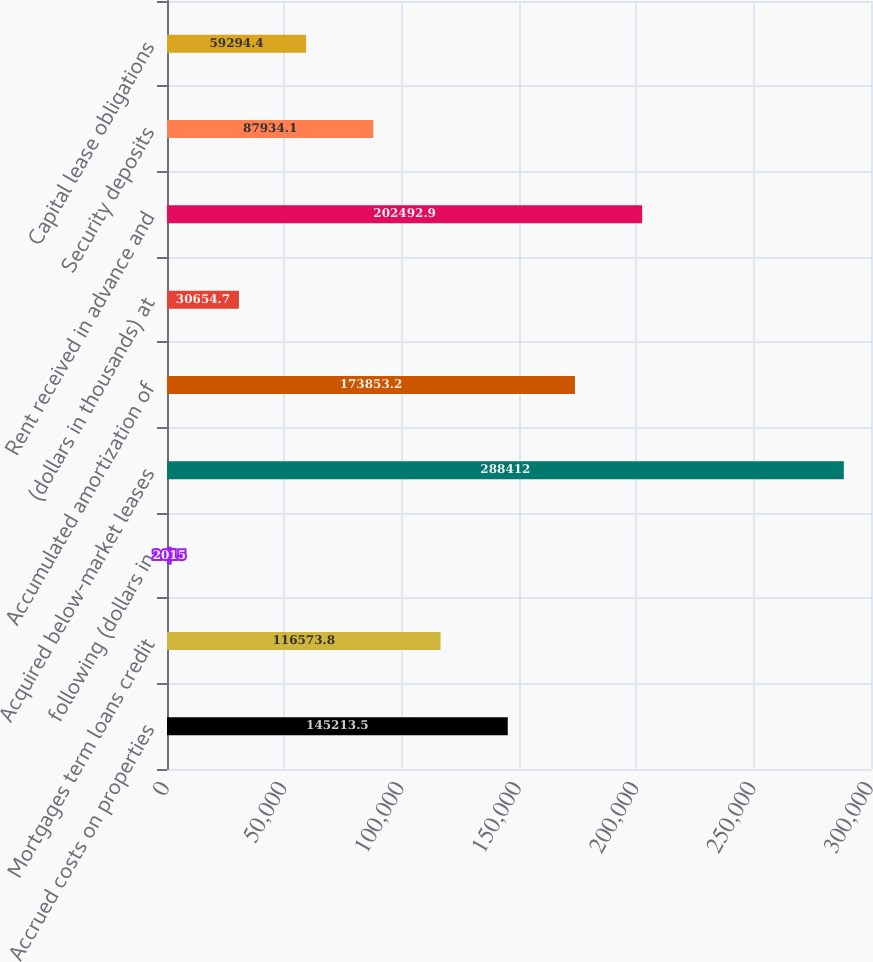Convert chart. <chart><loc_0><loc_0><loc_500><loc_500><bar_chart><fcel>Accrued costs on properties<fcel>Mortgages term loans credit<fcel>following (dollars in<fcel>Acquired below-market leases<fcel>Accumulated amortization of<fcel>(dollars in thousands) at<fcel>Rent received in advance and<fcel>Security deposits<fcel>Capital lease obligations<nl><fcel>145214<fcel>116574<fcel>2015<fcel>288412<fcel>173853<fcel>30654.7<fcel>202493<fcel>87934.1<fcel>59294.4<nl></chart> 